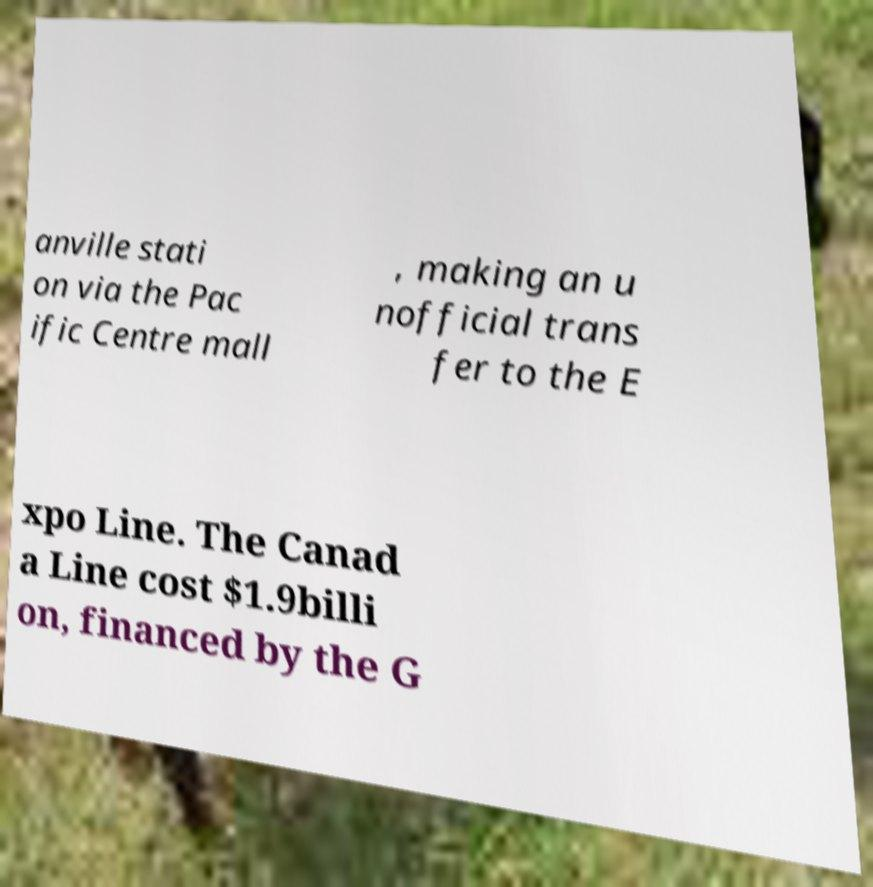What messages or text are displayed in this image? I need them in a readable, typed format. anville stati on via the Pac ific Centre mall , making an u nofficial trans fer to the E xpo Line. The Canad a Line cost $1.9billi on, financed by the G 